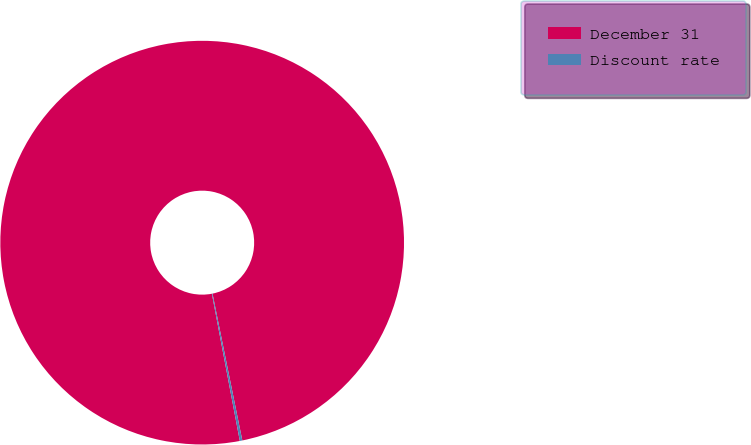Convert chart to OTSL. <chart><loc_0><loc_0><loc_500><loc_500><pie_chart><fcel>December 31<fcel>Discount rate<nl><fcel>99.8%<fcel>0.2%<nl></chart> 